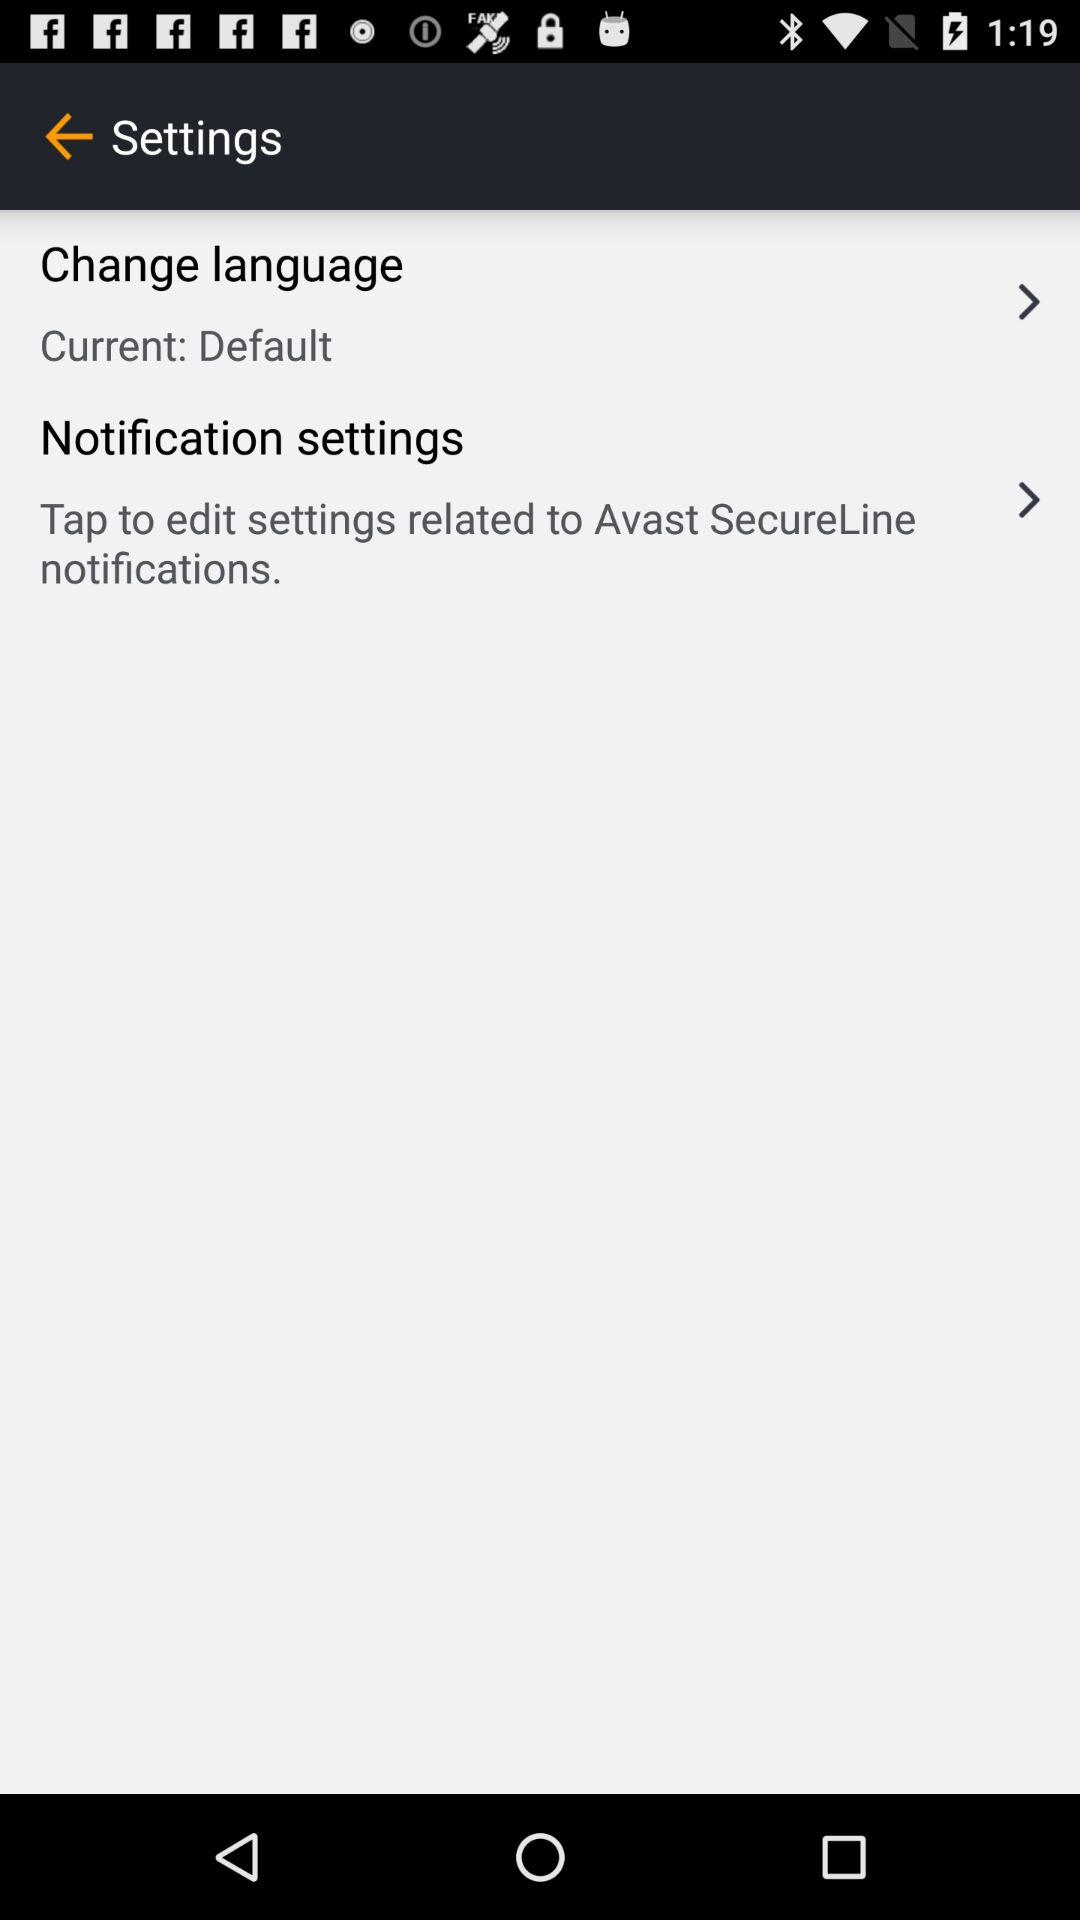What is the current setting for the "Notifications settings"? The current setting for the "Notifications settings" is "Tap to edit settings related to Avast SecureLine notifications.". 